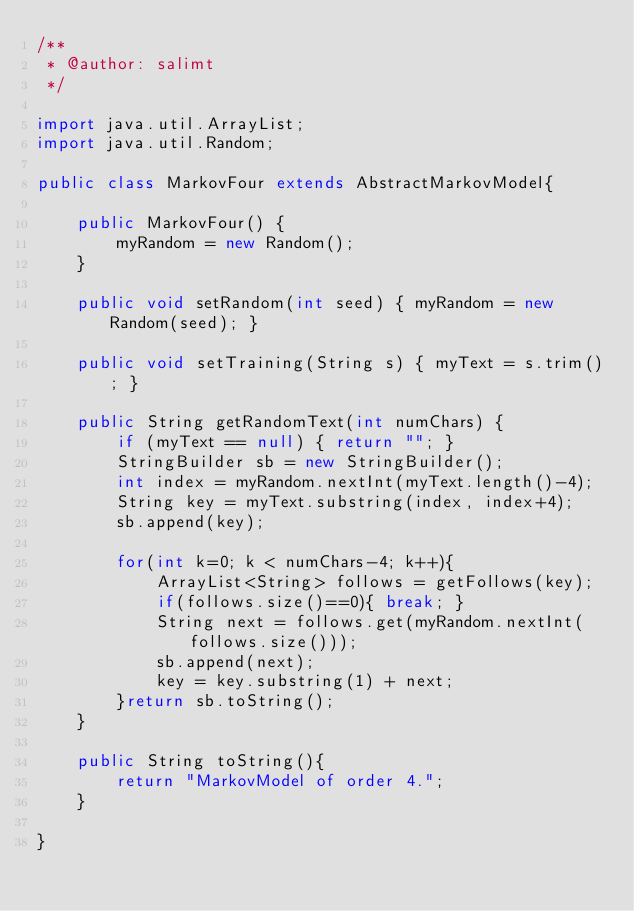<code> <loc_0><loc_0><loc_500><loc_500><_Java_>/**
 * @author: salimt
 */

import java.util.ArrayList;
import java.util.Random;

public class MarkovFour extends AbstractMarkovModel{

    public MarkovFour() {
        myRandom = new Random();
    }

    public void setRandom(int seed) { myRandom = new Random(seed); }

    public void setTraining(String s) { myText = s.trim(); }

    public String getRandomText(int numChars) {
        if (myText == null) { return ""; }
        StringBuilder sb = new StringBuilder();
        int index = myRandom.nextInt(myText.length()-4);
        String key = myText.substring(index, index+4);
        sb.append(key);

        for(int k=0; k < numChars-4; k++){
            ArrayList<String> follows = getFollows(key);
            if(follows.size()==0){ break; }
            String next = follows.get(myRandom.nextInt(follows.size()));
            sb.append(next);
            key = key.substring(1) + next;
        }return sb.toString();
    }

    public String toString(){
        return "MarkovModel of order 4.";
    }

}

</code> 